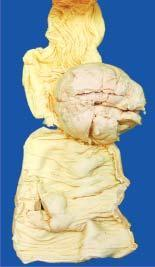s gomori methenamine silver ulcerated?
Answer the question using a single word or phrase. No 